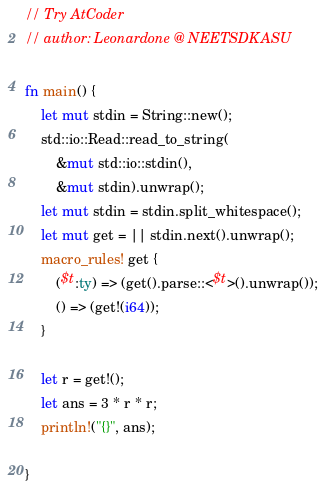<code> <loc_0><loc_0><loc_500><loc_500><_Rust_>// Try AtCoder
// author: Leonardone @ NEETSDKASU

fn main() {
    let mut stdin = String::new();
    std::io::Read::read_to_string(
        &mut std::io::stdin(),
        &mut stdin).unwrap();
    let mut stdin = stdin.split_whitespace();
    let mut get = || stdin.next().unwrap();
    macro_rules! get {
        ($t:ty) => (get().parse::<$t>().unwrap());
        () => (get!(i64));
    }
    
    let r = get!();
    let ans = 3 * r * r;
    println!("{}", ans);
    
}</code> 